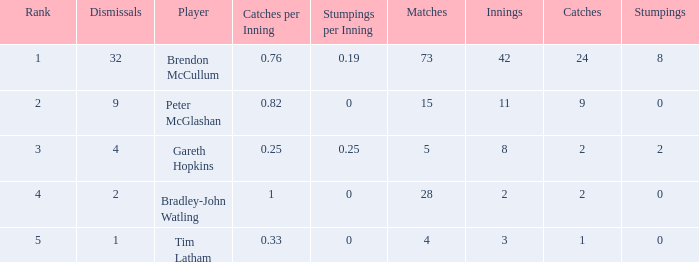Write the full table. {'header': ['Rank', 'Dismissals', 'Player', 'Catches per Inning', 'Stumpings per Inning', 'Matches', 'Innings', 'Catches', 'Stumpings'], 'rows': [['1', '32', 'Brendon McCullum', '0.76', '0.19', '73', '42', '24', '8'], ['2', '9', 'Peter McGlashan', '0.82', '0', '15', '11', '9', '0'], ['3', '4', 'Gareth Hopkins', '0.25', '0.25', '5', '8', '2', '2'], ['4', '2', 'Bradley-John Watling', '1', '0', '28', '2', '2', '0'], ['5', '1', 'Tim Latham', '0.33', '0', '4', '3', '1', '0']]} List the ranks of all dismissals with a value of 4 3.0. 